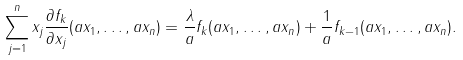Convert formula to latex. <formula><loc_0><loc_0><loc_500><loc_500>\sum _ { j = 1 } ^ { n } x _ { j } \frac { \partial f _ { k } } { \partial x _ { j } } ( a x _ { 1 } , \dots , a x _ { n } ) = \frac { \lambda } { a } f _ { k } ( a x _ { 1 } , \dots , a x _ { n } ) + \frac { 1 } { a } f _ { k - 1 } ( a x _ { 1 } , \dots , a x _ { n } ) . \\</formula> 